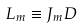<formula> <loc_0><loc_0><loc_500><loc_500>L _ { m } \equiv J _ { m } D</formula> 